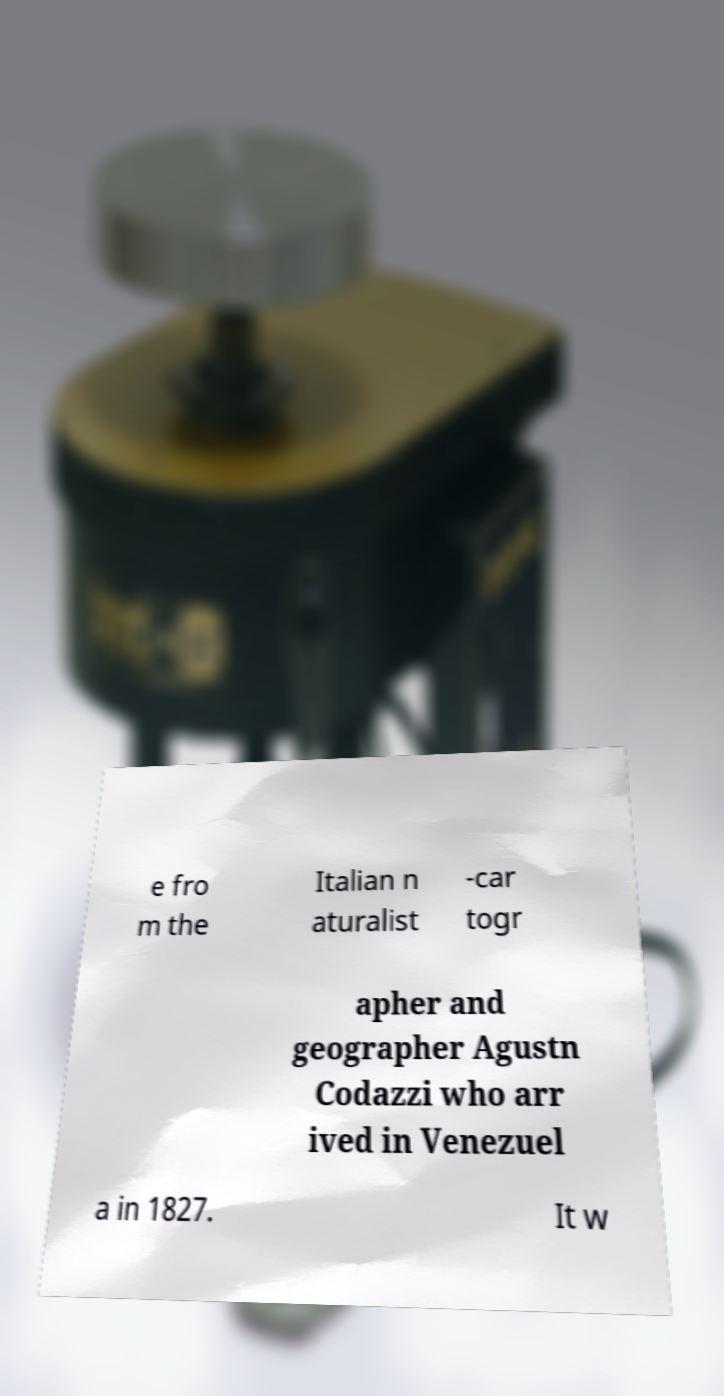I need the written content from this picture converted into text. Can you do that? e fro m the Italian n aturalist -car togr apher and geographer Agustn Codazzi who arr ived in Venezuel a in 1827. It w 